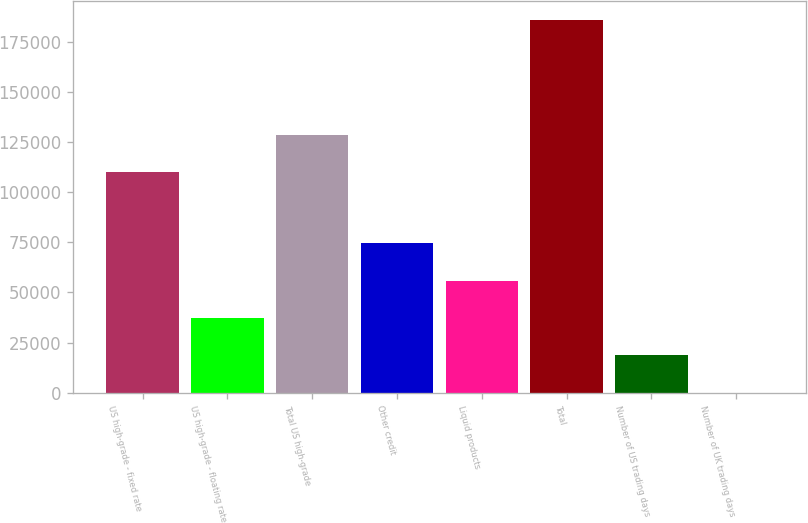Convert chart. <chart><loc_0><loc_0><loc_500><loc_500><bar_chart><fcel>US high-grade - fixed rate<fcel>US high-grade - floating rate<fcel>Total US high-grade<fcel>Other credit<fcel>Liquid products<fcel>Total<fcel>Number of US trading days<fcel>Number of UK trading days<nl><fcel>109970<fcel>37256.2<fcel>128568<fcel>74451.4<fcel>55853.8<fcel>186037<fcel>18658.6<fcel>61<nl></chart> 